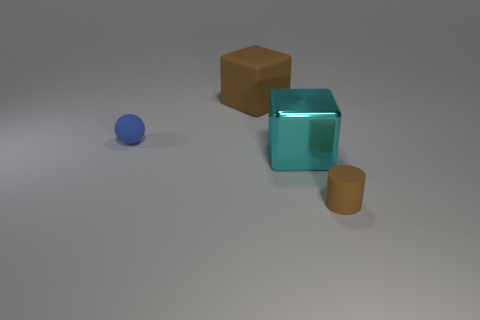Add 1 large metal objects. How many objects exist? 5 Subtract all brown cubes. How many cubes are left? 1 Subtract all balls. How many objects are left? 3 Add 3 rubber cylinders. How many rubber cylinders are left? 4 Add 2 big rubber cylinders. How many big rubber cylinders exist? 2 Subtract 0 red spheres. How many objects are left? 4 Subtract 1 spheres. How many spheres are left? 0 Subtract all gray blocks. Subtract all purple cylinders. How many blocks are left? 2 Subtract all brown cylinders. How many green balls are left? 0 Subtract all small gray objects. Subtract all metal objects. How many objects are left? 3 